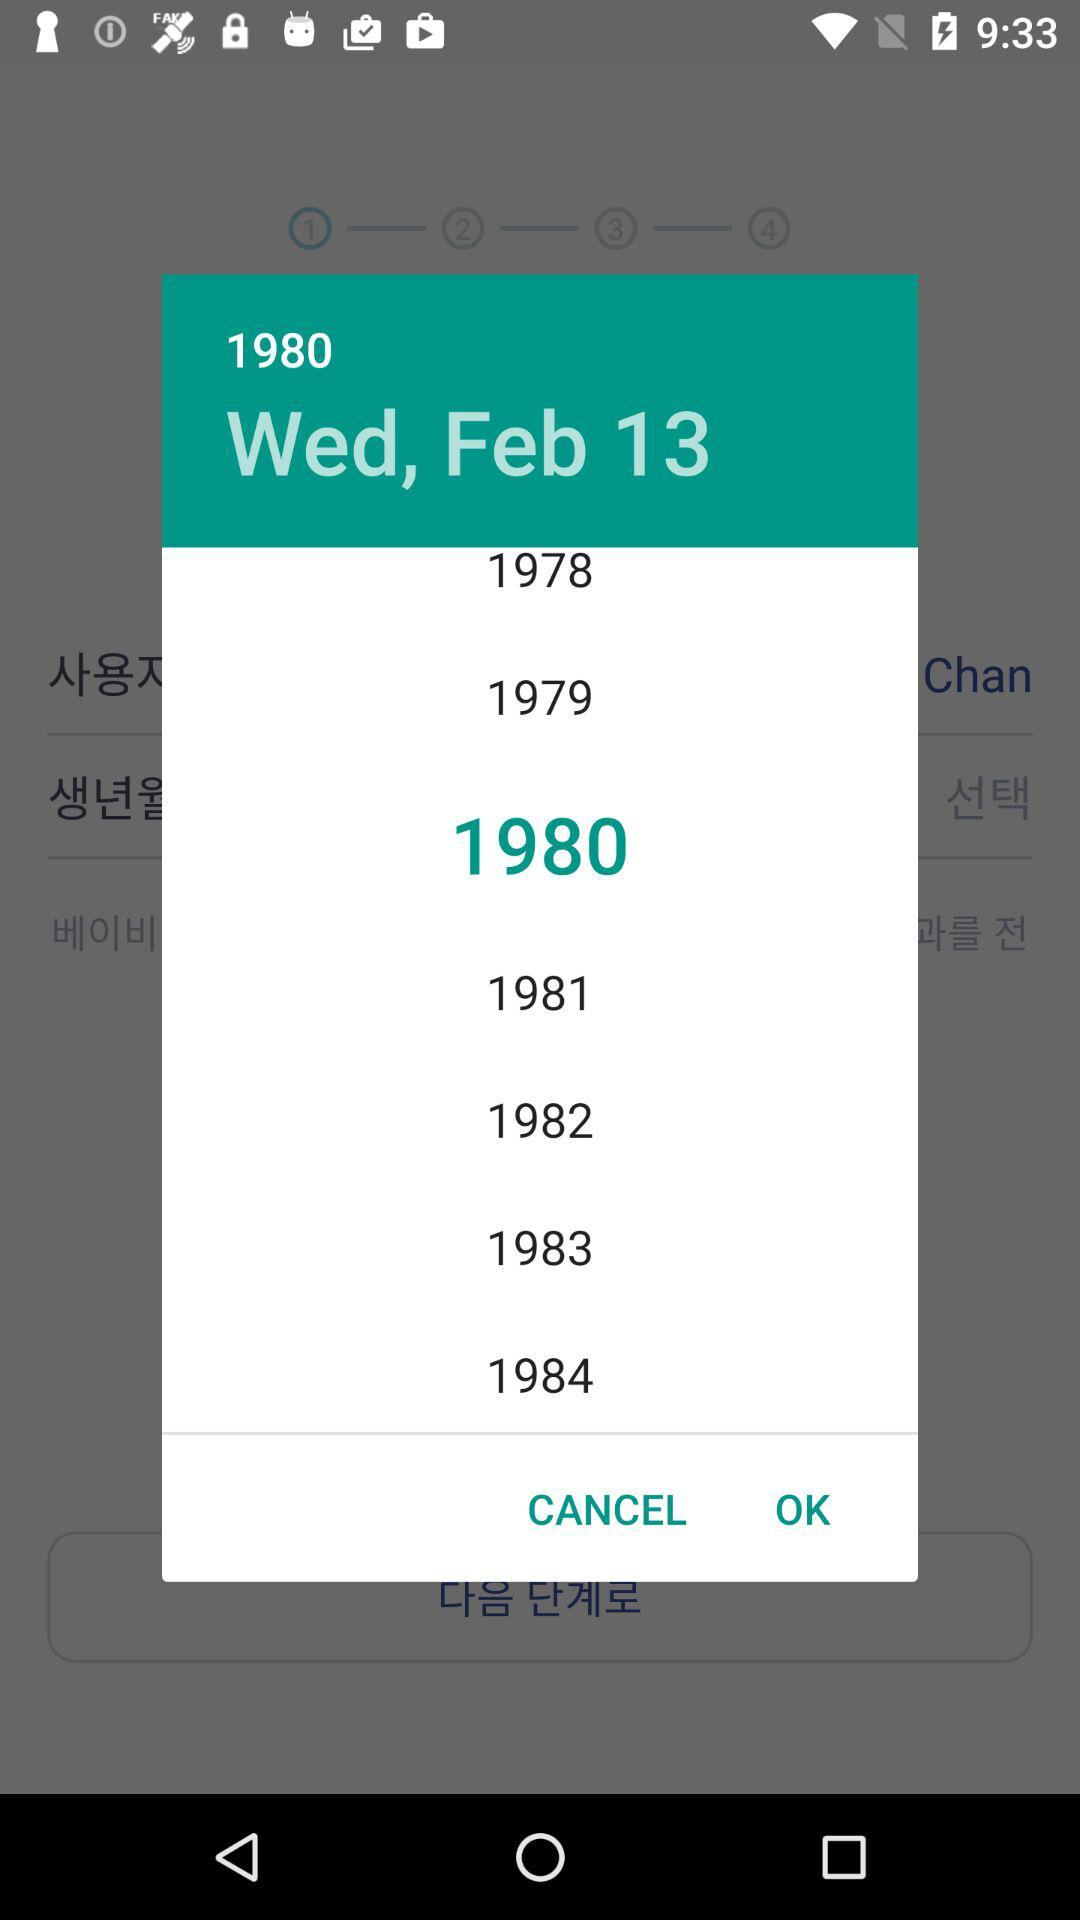Which year is selected? The selected year is 1980. 